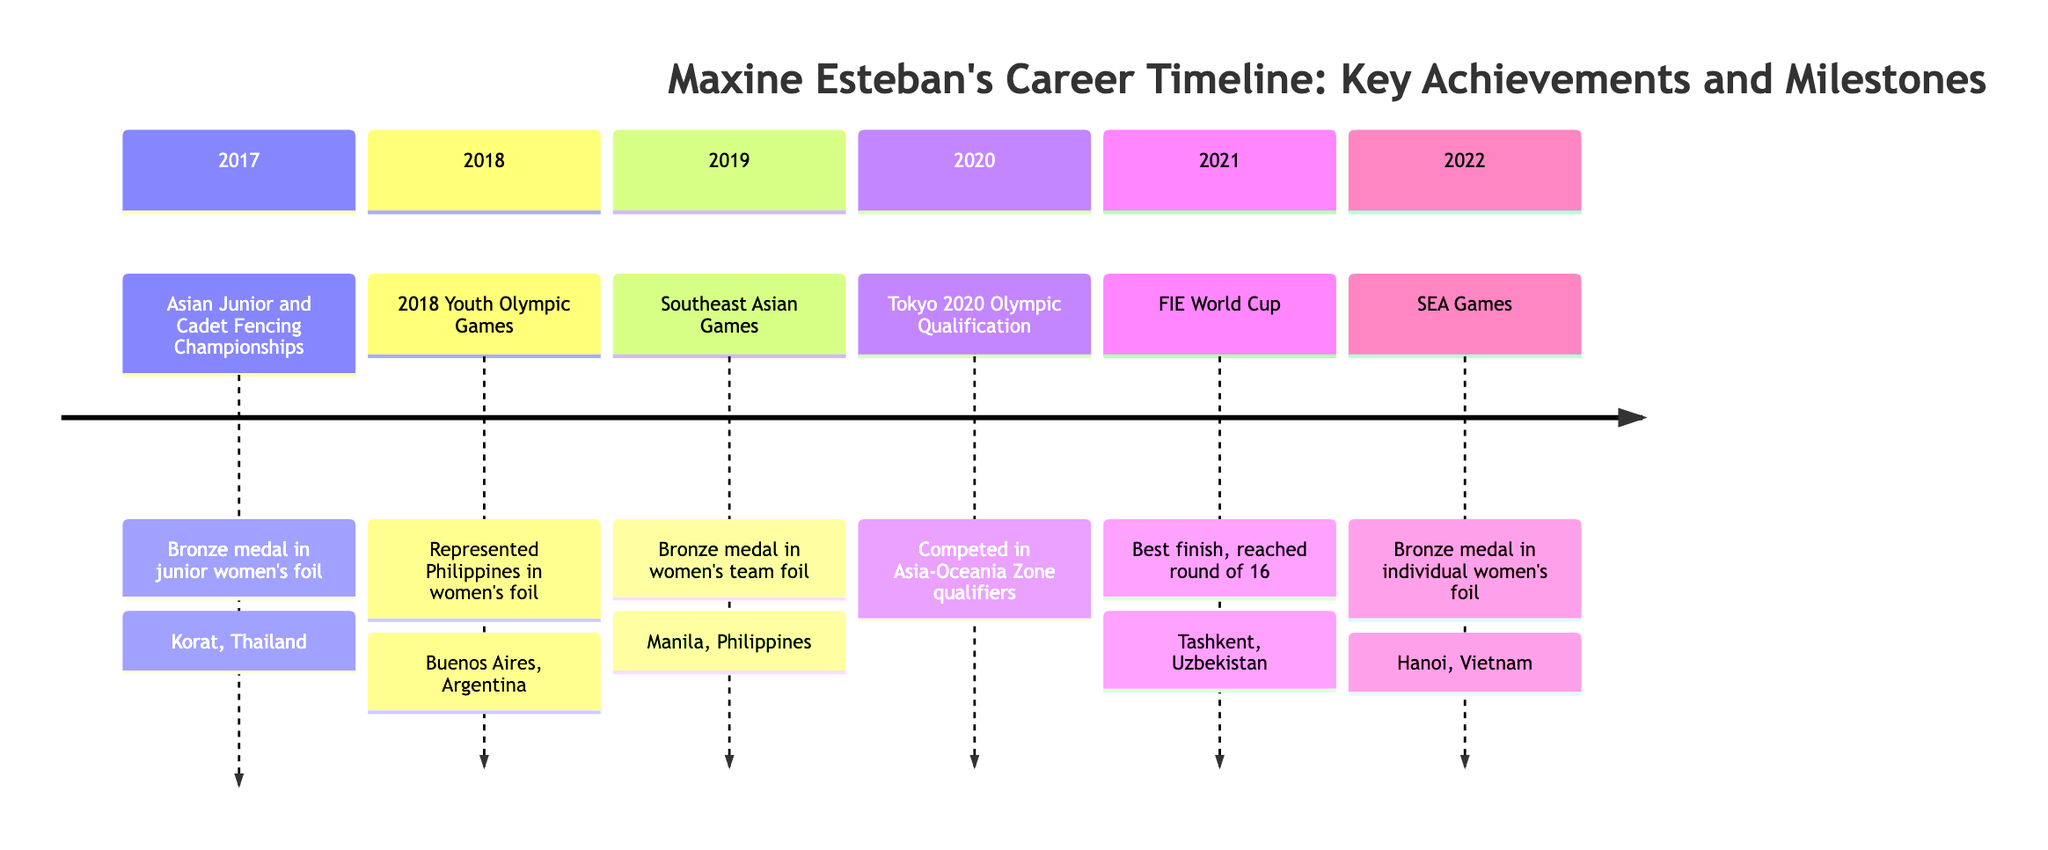What year did Maxine Esteban win her first international medal? The diagram shows that Maxine Esteban earned her first international medal in 2017 at the Asian Junior and Cadet Fencing Championships.
Answer: 2017 What medal did Maxine Esteban achieve at the SEA Games in 2019? According to the diagram, she won a bronze medal in the women's team foil event during the Southeast Asian Games in 2019.
Answer: Bronze Where did Maxine Esteban compete in 2020? The block for 2020 states that she competed in the Tokyo 2020 Olympic Qualification in the Asia-Oceania Zone.
Answer: Asia-Oceania Zone What was Maxine Esteban's best finish in the FIE World Cup? The diagram indicates that in 2021, her best finish in the FIE World Cup was reaching the round of 16.
Answer: Round of 16 Which event did she represent the Philippines in 2018? The block for 2018 shows that she represented the Philippines in the women's foil at the 2018 Youth Olympic Games.
Answer: Women's foil How many years did it take for Maxine Esteban to win her first SEA Games medal after her first international medal? From 2017 (first medal) to 2019 (first SEA Games medal) spans 2 years, as outlined in the timeline.
Answer: 2 years What distinguished achievement did Maxine Esteban have in 2022? In the year 2022, she achieved a bronze medal in the individual women's foil event at the SEA Games, as noted in the diagram.
Answer: Bronze medal Which event took place in Buenos Aires? As shown in the 2018 block, the 2018 Youth Olympic Games took place in Buenos Aires, Argentina.
Answer: 2018 Youth Olympic Games Which country hosted the Asian Junior and Cadet Fencing Championships in 2017? The 2017 block specifies that the Asian Junior and Cadet Fencing Championships were held in Korat, Thailand.
Answer: Thailand 